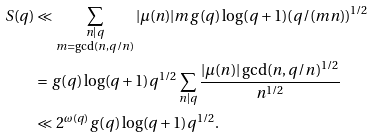<formula> <loc_0><loc_0><loc_500><loc_500>S ( q ) & \ll \sum _ { \substack { n | q \\ m = \gcd ( n , q / n ) } } | \mu ( n ) | m g ( q ) \log ( q + 1 ) ( q / ( m n ) ) ^ { 1 / 2 } \\ & = g ( q ) \log ( q + 1 ) q ^ { 1 / 2 } \sum _ { n | q } \frac { | \mu ( n ) | \gcd ( n , q / n ) ^ { 1 / 2 } } { n ^ { 1 / 2 } } \\ & \ll 2 ^ { \omega ( q ) } g ( q ) \log ( q + 1 ) q ^ { 1 / 2 } .</formula> 